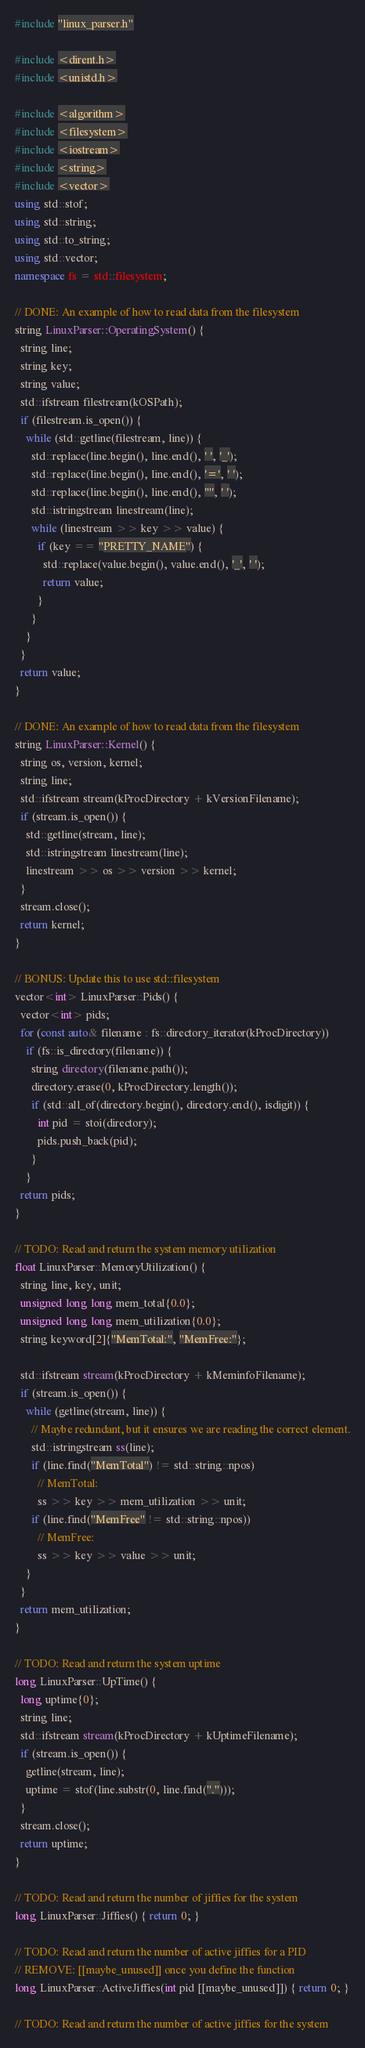<code> <loc_0><loc_0><loc_500><loc_500><_C++_>#include "linux_parser.h"

#include <dirent.h>
#include <unistd.h>

#include <algorithm>
#include <filesystem>
#include <iostream>
#include <string>
#include <vector>
using std::stof;
using std::string;
using std::to_string;
using std::vector;
namespace fs = std::filesystem;

// DONE: An example of how to read data from the filesystem
string LinuxParser::OperatingSystem() {
  string line;
  string key;
  string value;
  std::ifstream filestream(kOSPath);
  if (filestream.is_open()) {
    while (std::getline(filestream, line)) {
      std::replace(line.begin(), line.end(), ' ', '_');
      std::replace(line.begin(), line.end(), '=', ' ');
      std::replace(line.begin(), line.end(), '"', ' ');
      std::istringstream linestream(line);
      while (linestream >> key >> value) {
        if (key == "PRETTY_NAME") {
          std::replace(value.begin(), value.end(), '_', ' ');
          return value;
        }
      }
    }
  }
  return value;
}

// DONE: An example of how to read data from the filesystem
string LinuxParser::Kernel() {
  string os, version, kernel;
  string line;
  std::ifstream stream(kProcDirectory + kVersionFilename);
  if (stream.is_open()) {
    std::getline(stream, line);
    std::istringstream linestream(line);
    linestream >> os >> version >> kernel;
  }
  stream.close();
  return kernel;
}

// BONUS: Update this to use std::filesystem
vector<int> LinuxParser::Pids() {
  vector<int> pids;
  for (const auto& filename : fs::directory_iterator(kProcDirectory))
    if (fs::is_directory(filename)) {
      string directory(filename.path());
      directory.erase(0, kProcDirectory.length());
      if (std::all_of(directory.begin(), directory.end(), isdigit)) {
        int pid = stoi(directory);
        pids.push_back(pid);
      }
    }
  return pids;
}

// TODO: Read and return the system memory utilization
float LinuxParser::MemoryUtilization() {
  string line, key, unit;
  unsigned long long mem_total{0.0};
  unsigned long long mem_utilization{0.0};
  string keyword[2]{"MemTotal:", "MemFree:"};

  std::ifstream stream(kProcDirectory + kMeminfoFilename);
  if (stream.is_open()) {
    while (getline(stream, line)) {
      // Maybe redundant, but it ensures we are reading the correct element.
      std::istringstream ss(line);
      if (line.find("MemTotal") != std::string::npos)
        // MemTotal:
        ss >> key >> mem_utilization >> unit;
      if (line.find("MemFree" != std::string::npos))
        // MemFree:
        ss >> key >> value >> unit;
    }
  }
  return mem_utilization;
}

// TODO: Read and return the system uptime
long LinuxParser::UpTime() {
  long uptime{0};
  string line;
  std::ifstream stream(kProcDirectory + kUptimeFilename);
  if (stream.is_open()) {
    getline(stream, line);
    uptime = stof(line.substr(0, line.find(".")));
  }
  stream.close();
  return uptime;
}

// TODO: Read and return the number of jiffies for the system
long LinuxParser::Jiffies() { return 0; }

// TODO: Read and return the number of active jiffies for a PID
// REMOVE: [[maybe_unused]] once you define the function
long LinuxParser::ActiveJiffies(int pid [[maybe_unused]]) { return 0; }

// TODO: Read and return the number of active jiffies for the system</code> 